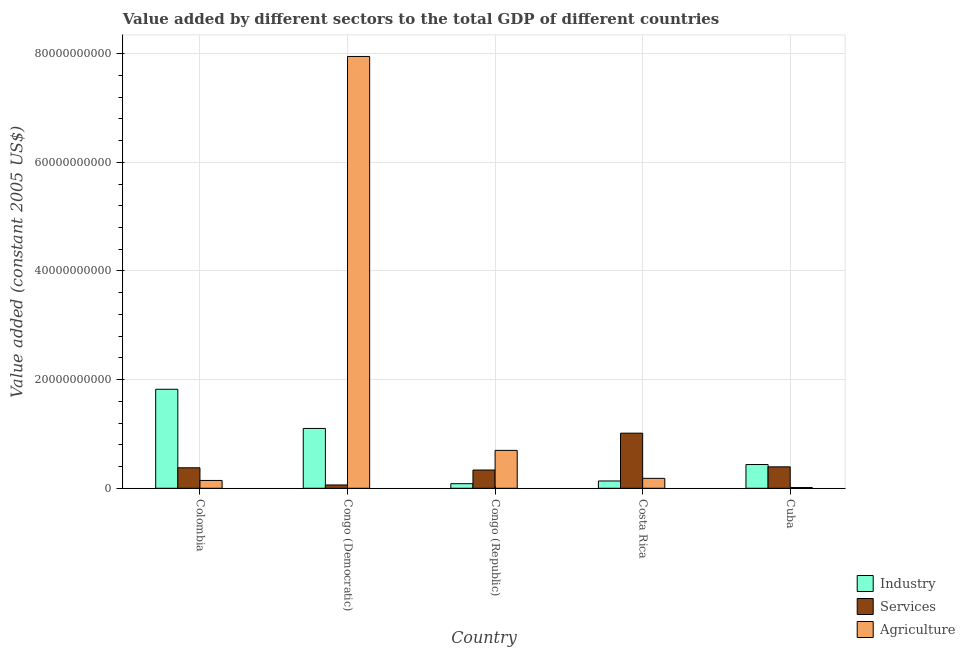How many different coloured bars are there?
Ensure brevity in your answer.  3. Are the number of bars on each tick of the X-axis equal?
Make the answer very short. Yes. How many bars are there on the 1st tick from the left?
Provide a succinct answer. 3. What is the label of the 2nd group of bars from the left?
Your answer should be very brief. Congo (Democratic). In how many cases, is the number of bars for a given country not equal to the number of legend labels?
Your answer should be compact. 0. What is the value added by industrial sector in Congo (Democratic)?
Your answer should be compact. 1.10e+1. Across all countries, what is the maximum value added by services?
Make the answer very short. 1.01e+1. Across all countries, what is the minimum value added by services?
Keep it short and to the point. 6.11e+08. In which country was the value added by agricultural sector maximum?
Offer a very short reply. Congo (Democratic). In which country was the value added by agricultural sector minimum?
Offer a terse response. Cuba. What is the total value added by industrial sector in the graph?
Offer a very short reply. 3.58e+1. What is the difference between the value added by industrial sector in Congo (Democratic) and that in Costa Rica?
Give a very brief answer. 9.67e+09. What is the difference between the value added by services in Congo (Republic) and the value added by industrial sector in Costa Rica?
Your response must be concise. 2.02e+09. What is the average value added by services per country?
Ensure brevity in your answer.  4.37e+09. What is the difference between the value added by services and value added by agricultural sector in Congo (Republic)?
Keep it short and to the point. -3.61e+09. In how many countries, is the value added by agricultural sector greater than 52000000000 US$?
Your answer should be compact. 1. What is the ratio of the value added by services in Colombia to that in Cuba?
Your response must be concise. 0.96. What is the difference between the highest and the second highest value added by agricultural sector?
Provide a short and direct response. 7.25e+1. What is the difference between the highest and the lowest value added by industrial sector?
Ensure brevity in your answer.  1.74e+1. What does the 3rd bar from the left in Congo (Republic) represents?
Your answer should be very brief. Agriculture. What does the 2nd bar from the right in Congo (Democratic) represents?
Make the answer very short. Services. Is it the case that in every country, the sum of the value added by industrial sector and value added by services is greater than the value added by agricultural sector?
Ensure brevity in your answer.  No. What is the difference between two consecutive major ticks on the Y-axis?
Keep it short and to the point. 2.00e+1. Are the values on the major ticks of Y-axis written in scientific E-notation?
Your answer should be compact. No. Does the graph contain any zero values?
Offer a terse response. No. Does the graph contain grids?
Make the answer very short. Yes. How many legend labels are there?
Keep it short and to the point. 3. How are the legend labels stacked?
Your response must be concise. Vertical. What is the title of the graph?
Your response must be concise. Value added by different sectors to the total GDP of different countries. What is the label or title of the X-axis?
Offer a very short reply. Country. What is the label or title of the Y-axis?
Give a very brief answer. Value added (constant 2005 US$). What is the Value added (constant 2005 US$) in Industry in Colombia?
Your response must be concise. 1.82e+1. What is the Value added (constant 2005 US$) of Services in Colombia?
Your answer should be very brief. 3.77e+09. What is the Value added (constant 2005 US$) in Agriculture in Colombia?
Provide a short and direct response. 1.44e+09. What is the Value added (constant 2005 US$) in Industry in Congo (Democratic)?
Provide a succinct answer. 1.10e+1. What is the Value added (constant 2005 US$) of Services in Congo (Democratic)?
Keep it short and to the point. 6.11e+08. What is the Value added (constant 2005 US$) of Agriculture in Congo (Democratic)?
Provide a succinct answer. 7.95e+1. What is the Value added (constant 2005 US$) in Industry in Congo (Republic)?
Your response must be concise. 8.43e+08. What is the Value added (constant 2005 US$) in Services in Congo (Republic)?
Provide a short and direct response. 3.36e+09. What is the Value added (constant 2005 US$) of Agriculture in Congo (Republic)?
Your answer should be compact. 6.97e+09. What is the Value added (constant 2005 US$) of Industry in Costa Rica?
Keep it short and to the point. 1.34e+09. What is the Value added (constant 2005 US$) in Services in Costa Rica?
Your answer should be compact. 1.01e+1. What is the Value added (constant 2005 US$) of Agriculture in Costa Rica?
Your response must be concise. 1.83e+09. What is the Value added (constant 2005 US$) in Industry in Cuba?
Offer a terse response. 4.37e+09. What is the Value added (constant 2005 US$) in Services in Cuba?
Your answer should be compact. 3.95e+09. What is the Value added (constant 2005 US$) of Agriculture in Cuba?
Your answer should be very brief. 1.36e+08. Across all countries, what is the maximum Value added (constant 2005 US$) of Industry?
Your response must be concise. 1.82e+1. Across all countries, what is the maximum Value added (constant 2005 US$) in Services?
Provide a short and direct response. 1.01e+1. Across all countries, what is the maximum Value added (constant 2005 US$) of Agriculture?
Offer a terse response. 7.95e+1. Across all countries, what is the minimum Value added (constant 2005 US$) in Industry?
Your response must be concise. 8.43e+08. Across all countries, what is the minimum Value added (constant 2005 US$) of Services?
Your response must be concise. 6.11e+08. Across all countries, what is the minimum Value added (constant 2005 US$) of Agriculture?
Your answer should be very brief. 1.36e+08. What is the total Value added (constant 2005 US$) of Industry in the graph?
Your answer should be very brief. 3.58e+1. What is the total Value added (constant 2005 US$) of Services in the graph?
Make the answer very short. 2.18e+1. What is the total Value added (constant 2005 US$) in Agriculture in the graph?
Your answer should be compact. 8.99e+1. What is the difference between the Value added (constant 2005 US$) of Industry in Colombia and that in Congo (Democratic)?
Make the answer very short. 7.21e+09. What is the difference between the Value added (constant 2005 US$) in Services in Colombia and that in Congo (Democratic)?
Your answer should be very brief. 3.16e+09. What is the difference between the Value added (constant 2005 US$) of Agriculture in Colombia and that in Congo (Democratic)?
Provide a succinct answer. -7.80e+1. What is the difference between the Value added (constant 2005 US$) of Industry in Colombia and that in Congo (Republic)?
Offer a terse response. 1.74e+1. What is the difference between the Value added (constant 2005 US$) in Services in Colombia and that in Congo (Republic)?
Provide a short and direct response. 4.11e+08. What is the difference between the Value added (constant 2005 US$) of Agriculture in Colombia and that in Congo (Republic)?
Your answer should be very brief. -5.53e+09. What is the difference between the Value added (constant 2005 US$) in Industry in Colombia and that in Costa Rica?
Provide a short and direct response. 1.69e+1. What is the difference between the Value added (constant 2005 US$) in Services in Colombia and that in Costa Rica?
Offer a very short reply. -6.37e+09. What is the difference between the Value added (constant 2005 US$) in Agriculture in Colombia and that in Costa Rica?
Keep it short and to the point. -3.86e+08. What is the difference between the Value added (constant 2005 US$) of Industry in Colombia and that in Cuba?
Make the answer very short. 1.39e+1. What is the difference between the Value added (constant 2005 US$) in Services in Colombia and that in Cuba?
Give a very brief answer. -1.73e+08. What is the difference between the Value added (constant 2005 US$) of Agriculture in Colombia and that in Cuba?
Ensure brevity in your answer.  1.31e+09. What is the difference between the Value added (constant 2005 US$) in Industry in Congo (Democratic) and that in Congo (Republic)?
Keep it short and to the point. 1.02e+1. What is the difference between the Value added (constant 2005 US$) of Services in Congo (Democratic) and that in Congo (Republic)?
Your response must be concise. -2.75e+09. What is the difference between the Value added (constant 2005 US$) of Agriculture in Congo (Democratic) and that in Congo (Republic)?
Offer a very short reply. 7.25e+1. What is the difference between the Value added (constant 2005 US$) of Industry in Congo (Democratic) and that in Costa Rica?
Your answer should be very brief. 9.67e+09. What is the difference between the Value added (constant 2005 US$) in Services in Congo (Democratic) and that in Costa Rica?
Your answer should be very brief. -9.53e+09. What is the difference between the Value added (constant 2005 US$) in Agriculture in Congo (Democratic) and that in Costa Rica?
Provide a succinct answer. 7.77e+1. What is the difference between the Value added (constant 2005 US$) of Industry in Congo (Democratic) and that in Cuba?
Make the answer very short. 6.64e+09. What is the difference between the Value added (constant 2005 US$) in Services in Congo (Democratic) and that in Cuba?
Provide a short and direct response. -3.33e+09. What is the difference between the Value added (constant 2005 US$) of Agriculture in Congo (Democratic) and that in Cuba?
Provide a succinct answer. 7.93e+1. What is the difference between the Value added (constant 2005 US$) of Industry in Congo (Republic) and that in Costa Rica?
Make the answer very short. -5.02e+08. What is the difference between the Value added (constant 2005 US$) of Services in Congo (Republic) and that in Costa Rica?
Offer a very short reply. -6.78e+09. What is the difference between the Value added (constant 2005 US$) of Agriculture in Congo (Republic) and that in Costa Rica?
Your answer should be compact. 5.15e+09. What is the difference between the Value added (constant 2005 US$) of Industry in Congo (Republic) and that in Cuba?
Provide a short and direct response. -3.53e+09. What is the difference between the Value added (constant 2005 US$) in Services in Congo (Republic) and that in Cuba?
Your response must be concise. -5.83e+08. What is the difference between the Value added (constant 2005 US$) in Agriculture in Congo (Republic) and that in Cuba?
Give a very brief answer. 6.84e+09. What is the difference between the Value added (constant 2005 US$) of Industry in Costa Rica and that in Cuba?
Ensure brevity in your answer.  -3.03e+09. What is the difference between the Value added (constant 2005 US$) of Services in Costa Rica and that in Cuba?
Offer a terse response. 6.20e+09. What is the difference between the Value added (constant 2005 US$) in Agriculture in Costa Rica and that in Cuba?
Offer a terse response. 1.69e+09. What is the difference between the Value added (constant 2005 US$) in Industry in Colombia and the Value added (constant 2005 US$) in Services in Congo (Democratic)?
Your answer should be compact. 1.76e+1. What is the difference between the Value added (constant 2005 US$) in Industry in Colombia and the Value added (constant 2005 US$) in Agriculture in Congo (Democratic)?
Provide a short and direct response. -6.13e+1. What is the difference between the Value added (constant 2005 US$) of Services in Colombia and the Value added (constant 2005 US$) of Agriculture in Congo (Democratic)?
Give a very brief answer. -7.57e+1. What is the difference between the Value added (constant 2005 US$) in Industry in Colombia and the Value added (constant 2005 US$) in Services in Congo (Republic)?
Offer a terse response. 1.49e+1. What is the difference between the Value added (constant 2005 US$) of Industry in Colombia and the Value added (constant 2005 US$) of Agriculture in Congo (Republic)?
Make the answer very short. 1.13e+1. What is the difference between the Value added (constant 2005 US$) of Services in Colombia and the Value added (constant 2005 US$) of Agriculture in Congo (Republic)?
Ensure brevity in your answer.  -3.20e+09. What is the difference between the Value added (constant 2005 US$) of Industry in Colombia and the Value added (constant 2005 US$) of Services in Costa Rica?
Keep it short and to the point. 8.08e+09. What is the difference between the Value added (constant 2005 US$) in Industry in Colombia and the Value added (constant 2005 US$) in Agriculture in Costa Rica?
Your answer should be very brief. 1.64e+1. What is the difference between the Value added (constant 2005 US$) in Services in Colombia and the Value added (constant 2005 US$) in Agriculture in Costa Rica?
Your answer should be compact. 1.94e+09. What is the difference between the Value added (constant 2005 US$) in Industry in Colombia and the Value added (constant 2005 US$) in Services in Cuba?
Offer a terse response. 1.43e+1. What is the difference between the Value added (constant 2005 US$) in Industry in Colombia and the Value added (constant 2005 US$) in Agriculture in Cuba?
Your answer should be compact. 1.81e+1. What is the difference between the Value added (constant 2005 US$) in Services in Colombia and the Value added (constant 2005 US$) in Agriculture in Cuba?
Provide a short and direct response. 3.64e+09. What is the difference between the Value added (constant 2005 US$) of Industry in Congo (Democratic) and the Value added (constant 2005 US$) of Services in Congo (Republic)?
Provide a succinct answer. 7.65e+09. What is the difference between the Value added (constant 2005 US$) in Industry in Congo (Democratic) and the Value added (constant 2005 US$) in Agriculture in Congo (Republic)?
Ensure brevity in your answer.  4.04e+09. What is the difference between the Value added (constant 2005 US$) of Services in Congo (Democratic) and the Value added (constant 2005 US$) of Agriculture in Congo (Republic)?
Ensure brevity in your answer.  -6.36e+09. What is the difference between the Value added (constant 2005 US$) of Industry in Congo (Democratic) and the Value added (constant 2005 US$) of Services in Costa Rica?
Give a very brief answer. 8.68e+08. What is the difference between the Value added (constant 2005 US$) of Industry in Congo (Democratic) and the Value added (constant 2005 US$) of Agriculture in Costa Rica?
Your answer should be compact. 9.19e+09. What is the difference between the Value added (constant 2005 US$) in Services in Congo (Democratic) and the Value added (constant 2005 US$) in Agriculture in Costa Rica?
Provide a succinct answer. -1.22e+09. What is the difference between the Value added (constant 2005 US$) in Industry in Congo (Democratic) and the Value added (constant 2005 US$) in Services in Cuba?
Give a very brief answer. 7.07e+09. What is the difference between the Value added (constant 2005 US$) in Industry in Congo (Democratic) and the Value added (constant 2005 US$) in Agriculture in Cuba?
Offer a very short reply. 1.09e+1. What is the difference between the Value added (constant 2005 US$) in Services in Congo (Democratic) and the Value added (constant 2005 US$) in Agriculture in Cuba?
Offer a very short reply. 4.75e+08. What is the difference between the Value added (constant 2005 US$) of Industry in Congo (Republic) and the Value added (constant 2005 US$) of Services in Costa Rica?
Your answer should be compact. -9.30e+09. What is the difference between the Value added (constant 2005 US$) of Industry in Congo (Republic) and the Value added (constant 2005 US$) of Agriculture in Costa Rica?
Offer a very short reply. -9.86e+08. What is the difference between the Value added (constant 2005 US$) in Services in Congo (Republic) and the Value added (constant 2005 US$) in Agriculture in Costa Rica?
Offer a very short reply. 1.53e+09. What is the difference between the Value added (constant 2005 US$) of Industry in Congo (Republic) and the Value added (constant 2005 US$) of Services in Cuba?
Give a very brief answer. -3.10e+09. What is the difference between the Value added (constant 2005 US$) of Industry in Congo (Republic) and the Value added (constant 2005 US$) of Agriculture in Cuba?
Give a very brief answer. 7.07e+08. What is the difference between the Value added (constant 2005 US$) of Services in Congo (Republic) and the Value added (constant 2005 US$) of Agriculture in Cuba?
Provide a succinct answer. 3.23e+09. What is the difference between the Value added (constant 2005 US$) in Industry in Costa Rica and the Value added (constant 2005 US$) in Services in Cuba?
Provide a short and direct response. -2.60e+09. What is the difference between the Value added (constant 2005 US$) of Industry in Costa Rica and the Value added (constant 2005 US$) of Agriculture in Cuba?
Offer a very short reply. 1.21e+09. What is the difference between the Value added (constant 2005 US$) in Services in Costa Rica and the Value added (constant 2005 US$) in Agriculture in Cuba?
Offer a terse response. 1.00e+1. What is the average Value added (constant 2005 US$) of Industry per country?
Give a very brief answer. 7.16e+09. What is the average Value added (constant 2005 US$) of Services per country?
Make the answer very short. 4.37e+09. What is the average Value added (constant 2005 US$) in Agriculture per country?
Make the answer very short. 1.80e+1. What is the difference between the Value added (constant 2005 US$) of Industry and Value added (constant 2005 US$) of Services in Colombia?
Provide a succinct answer. 1.45e+1. What is the difference between the Value added (constant 2005 US$) in Industry and Value added (constant 2005 US$) in Agriculture in Colombia?
Ensure brevity in your answer.  1.68e+1. What is the difference between the Value added (constant 2005 US$) of Services and Value added (constant 2005 US$) of Agriculture in Colombia?
Offer a terse response. 2.33e+09. What is the difference between the Value added (constant 2005 US$) of Industry and Value added (constant 2005 US$) of Services in Congo (Democratic)?
Ensure brevity in your answer.  1.04e+1. What is the difference between the Value added (constant 2005 US$) in Industry and Value added (constant 2005 US$) in Agriculture in Congo (Democratic)?
Keep it short and to the point. -6.85e+1. What is the difference between the Value added (constant 2005 US$) of Services and Value added (constant 2005 US$) of Agriculture in Congo (Democratic)?
Make the answer very short. -7.89e+1. What is the difference between the Value added (constant 2005 US$) in Industry and Value added (constant 2005 US$) in Services in Congo (Republic)?
Provide a short and direct response. -2.52e+09. What is the difference between the Value added (constant 2005 US$) of Industry and Value added (constant 2005 US$) of Agriculture in Congo (Republic)?
Make the answer very short. -6.13e+09. What is the difference between the Value added (constant 2005 US$) of Services and Value added (constant 2005 US$) of Agriculture in Congo (Republic)?
Your response must be concise. -3.61e+09. What is the difference between the Value added (constant 2005 US$) in Industry and Value added (constant 2005 US$) in Services in Costa Rica?
Give a very brief answer. -8.80e+09. What is the difference between the Value added (constant 2005 US$) in Industry and Value added (constant 2005 US$) in Agriculture in Costa Rica?
Provide a succinct answer. -4.84e+08. What is the difference between the Value added (constant 2005 US$) of Services and Value added (constant 2005 US$) of Agriculture in Costa Rica?
Provide a succinct answer. 8.32e+09. What is the difference between the Value added (constant 2005 US$) of Industry and Value added (constant 2005 US$) of Services in Cuba?
Your answer should be compact. 4.28e+08. What is the difference between the Value added (constant 2005 US$) of Industry and Value added (constant 2005 US$) of Agriculture in Cuba?
Provide a succinct answer. 4.24e+09. What is the difference between the Value added (constant 2005 US$) in Services and Value added (constant 2005 US$) in Agriculture in Cuba?
Keep it short and to the point. 3.81e+09. What is the ratio of the Value added (constant 2005 US$) of Industry in Colombia to that in Congo (Democratic)?
Ensure brevity in your answer.  1.65. What is the ratio of the Value added (constant 2005 US$) in Services in Colombia to that in Congo (Democratic)?
Make the answer very short. 6.17. What is the ratio of the Value added (constant 2005 US$) in Agriculture in Colombia to that in Congo (Democratic)?
Your answer should be very brief. 0.02. What is the ratio of the Value added (constant 2005 US$) of Industry in Colombia to that in Congo (Republic)?
Provide a succinct answer. 21.62. What is the ratio of the Value added (constant 2005 US$) in Services in Colombia to that in Congo (Republic)?
Ensure brevity in your answer.  1.12. What is the ratio of the Value added (constant 2005 US$) of Agriculture in Colombia to that in Congo (Republic)?
Offer a very short reply. 0.21. What is the ratio of the Value added (constant 2005 US$) of Industry in Colombia to that in Costa Rica?
Provide a short and direct response. 13.55. What is the ratio of the Value added (constant 2005 US$) of Services in Colombia to that in Costa Rica?
Your answer should be very brief. 0.37. What is the ratio of the Value added (constant 2005 US$) of Agriculture in Colombia to that in Costa Rica?
Keep it short and to the point. 0.79. What is the ratio of the Value added (constant 2005 US$) of Industry in Colombia to that in Cuba?
Offer a terse response. 4.17. What is the ratio of the Value added (constant 2005 US$) in Services in Colombia to that in Cuba?
Provide a succinct answer. 0.96. What is the ratio of the Value added (constant 2005 US$) of Agriculture in Colombia to that in Cuba?
Your response must be concise. 10.61. What is the ratio of the Value added (constant 2005 US$) of Industry in Congo (Democratic) to that in Congo (Republic)?
Your answer should be very brief. 13.07. What is the ratio of the Value added (constant 2005 US$) in Services in Congo (Democratic) to that in Congo (Republic)?
Your answer should be compact. 0.18. What is the ratio of the Value added (constant 2005 US$) of Agriculture in Congo (Democratic) to that in Congo (Republic)?
Your answer should be very brief. 11.4. What is the ratio of the Value added (constant 2005 US$) of Industry in Congo (Democratic) to that in Costa Rica?
Ensure brevity in your answer.  8.19. What is the ratio of the Value added (constant 2005 US$) in Services in Congo (Democratic) to that in Costa Rica?
Offer a terse response. 0.06. What is the ratio of the Value added (constant 2005 US$) in Agriculture in Congo (Democratic) to that in Costa Rica?
Ensure brevity in your answer.  43.46. What is the ratio of the Value added (constant 2005 US$) of Industry in Congo (Democratic) to that in Cuba?
Make the answer very short. 2.52. What is the ratio of the Value added (constant 2005 US$) of Services in Congo (Democratic) to that in Cuba?
Your response must be concise. 0.15. What is the ratio of the Value added (constant 2005 US$) in Agriculture in Congo (Democratic) to that in Cuba?
Your answer should be compact. 584.5. What is the ratio of the Value added (constant 2005 US$) of Industry in Congo (Republic) to that in Costa Rica?
Offer a very short reply. 0.63. What is the ratio of the Value added (constant 2005 US$) in Services in Congo (Republic) to that in Costa Rica?
Ensure brevity in your answer.  0.33. What is the ratio of the Value added (constant 2005 US$) of Agriculture in Congo (Republic) to that in Costa Rica?
Make the answer very short. 3.81. What is the ratio of the Value added (constant 2005 US$) of Industry in Congo (Republic) to that in Cuba?
Offer a very short reply. 0.19. What is the ratio of the Value added (constant 2005 US$) of Services in Congo (Republic) to that in Cuba?
Your response must be concise. 0.85. What is the ratio of the Value added (constant 2005 US$) in Agriculture in Congo (Republic) to that in Cuba?
Offer a very short reply. 51.29. What is the ratio of the Value added (constant 2005 US$) in Industry in Costa Rica to that in Cuba?
Ensure brevity in your answer.  0.31. What is the ratio of the Value added (constant 2005 US$) in Services in Costa Rica to that in Cuba?
Make the answer very short. 2.57. What is the ratio of the Value added (constant 2005 US$) of Agriculture in Costa Rica to that in Cuba?
Your response must be concise. 13.45. What is the difference between the highest and the second highest Value added (constant 2005 US$) in Industry?
Provide a short and direct response. 7.21e+09. What is the difference between the highest and the second highest Value added (constant 2005 US$) in Services?
Your answer should be very brief. 6.20e+09. What is the difference between the highest and the second highest Value added (constant 2005 US$) in Agriculture?
Make the answer very short. 7.25e+1. What is the difference between the highest and the lowest Value added (constant 2005 US$) in Industry?
Provide a succinct answer. 1.74e+1. What is the difference between the highest and the lowest Value added (constant 2005 US$) in Services?
Provide a succinct answer. 9.53e+09. What is the difference between the highest and the lowest Value added (constant 2005 US$) in Agriculture?
Your answer should be compact. 7.93e+1. 